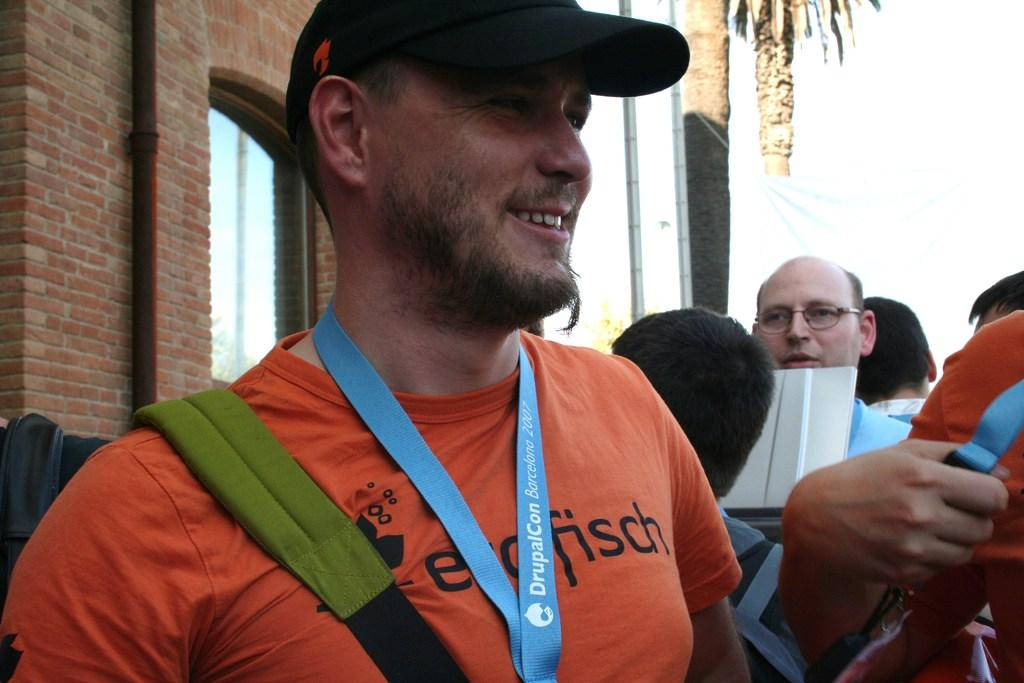How many people are in the image? There are people in the image, but the exact number is not specified. Can you describe the man in the image? The man is wearing a tag and a cap, and he is smiling. What can be seen in the background of the image? There are windows, a brick wall, and trees in the background of the image. What type of wren is perched on the man's shoulder in the image? There is no wren present in the image; it only features people, a man with a tag and cap, and a background with windows, a brick wall, and trees. 